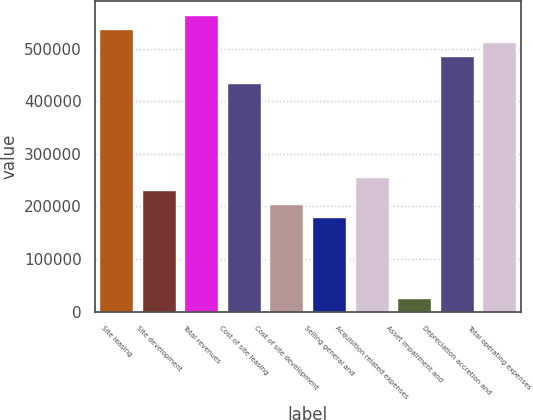Convert chart to OTSL. <chart><loc_0><loc_0><loc_500><loc_500><bar_chart><fcel>Site leasing<fcel>Site development<fcel>Total revenues<fcel>Cost of site leasing<fcel>Cost of site development<fcel>Selling general and<fcel>Acquisition related expenses<fcel>Asset impairment and<fcel>Depreciation accretion and<fcel>Total operating expenses<nl><fcel>537328<fcel>230331<fcel>562911<fcel>434996<fcel>204748<fcel>179165<fcel>255914<fcel>25666.1<fcel>486162<fcel>511745<nl></chart> 